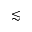Convert formula to latex. <formula><loc_0><loc_0><loc_500><loc_500>\lesssim</formula> 